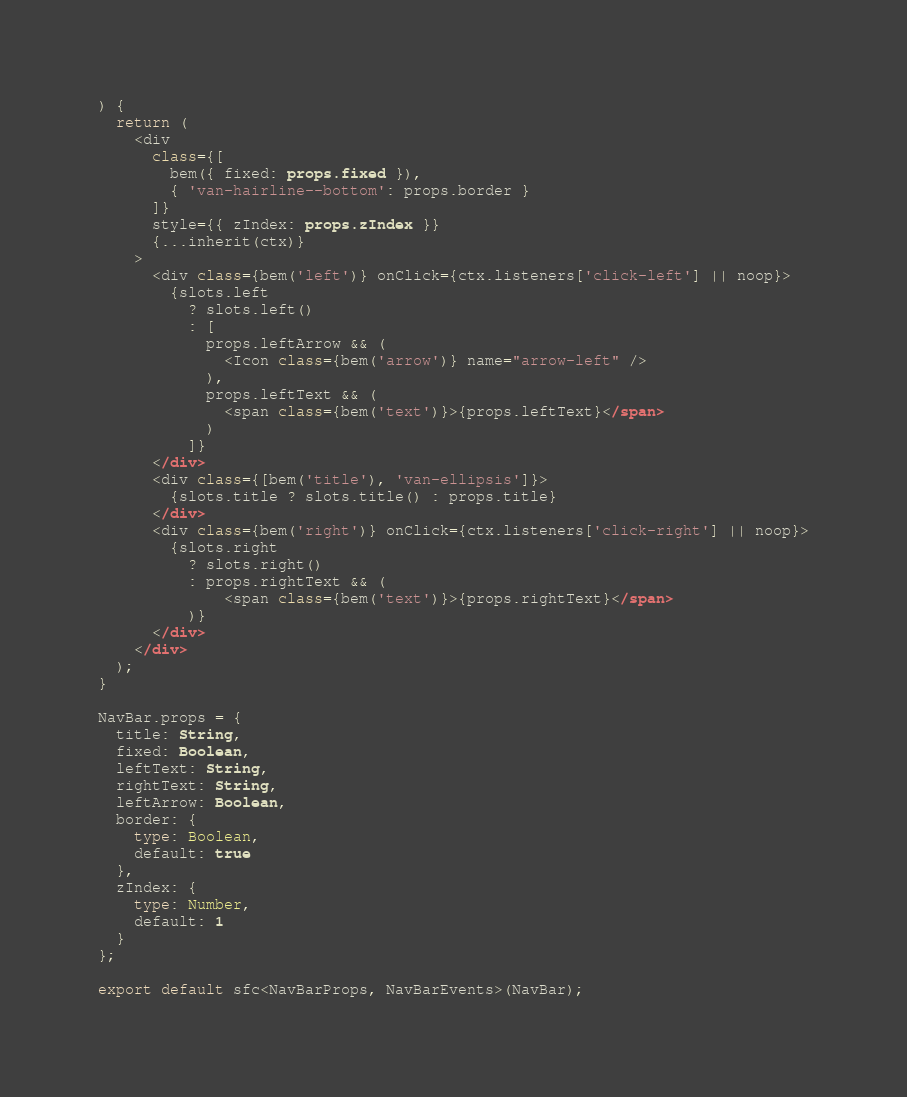<code> <loc_0><loc_0><loc_500><loc_500><_TypeScript_>) {
  return (
    <div
      class={[
        bem({ fixed: props.fixed }),
        { 'van-hairline--bottom': props.border }
      ]}
      style={{ zIndex: props.zIndex }}
      {...inherit(ctx)}
    >
      <div class={bem('left')} onClick={ctx.listeners['click-left'] || noop}>
        {slots.left
          ? slots.left()
          : [
            props.leftArrow && (
              <Icon class={bem('arrow')} name="arrow-left" />
            ),
            props.leftText && (
              <span class={bem('text')}>{props.leftText}</span>
            )
          ]}
      </div>
      <div class={[bem('title'), 'van-ellipsis']}>
        {slots.title ? slots.title() : props.title}
      </div>
      <div class={bem('right')} onClick={ctx.listeners['click-right'] || noop}>
        {slots.right
          ? slots.right()
          : props.rightText && (
              <span class={bem('text')}>{props.rightText}</span>
          )}
      </div>
    </div>
  );
}

NavBar.props = {
  title: String,
  fixed: Boolean,
  leftText: String,
  rightText: String,
  leftArrow: Boolean,
  border: {
    type: Boolean,
    default: true
  },
  zIndex: {
    type: Number,
    default: 1
  }
};

export default sfc<NavBarProps, NavBarEvents>(NavBar);
</code> 